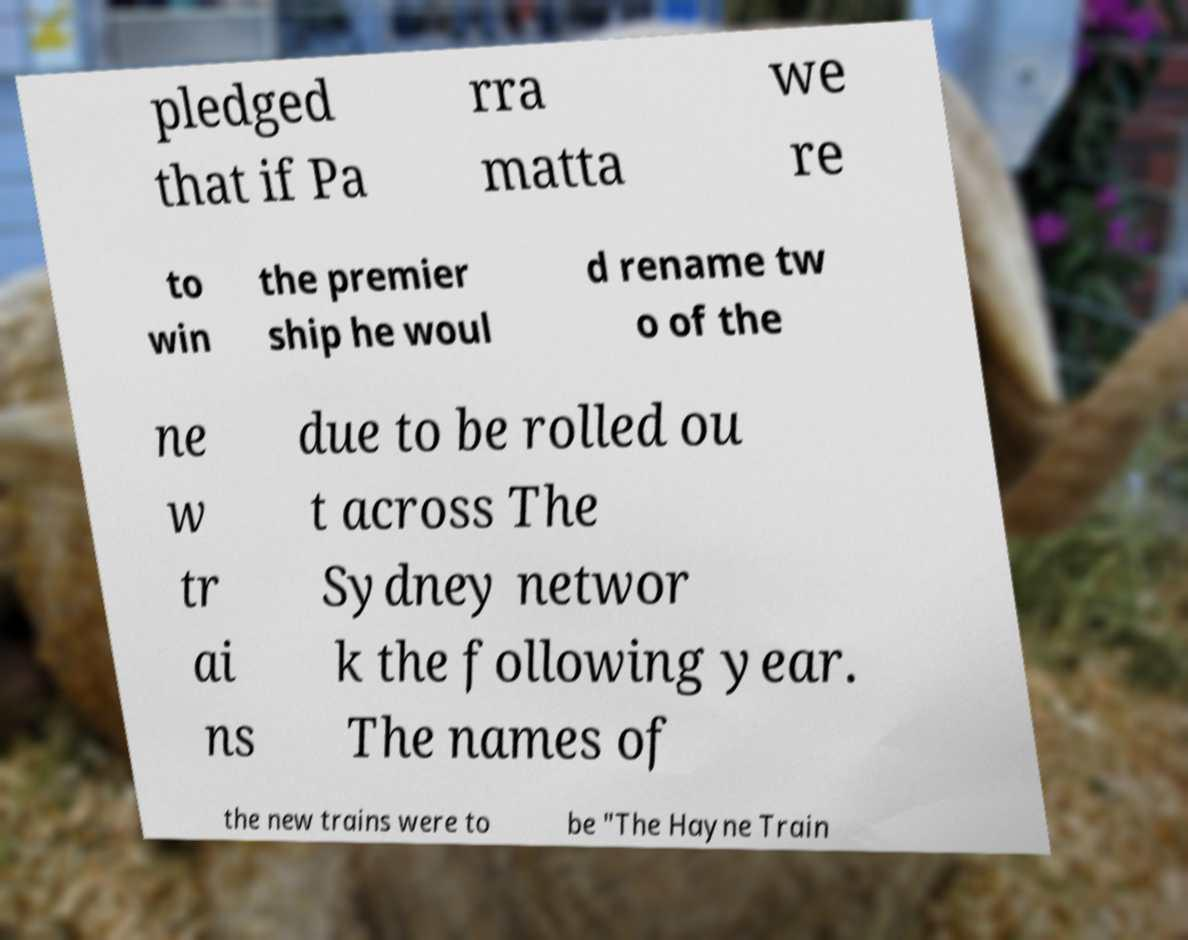Can you accurately transcribe the text from the provided image for me? pledged that if Pa rra matta we re to win the premier ship he woul d rename tw o of the ne w tr ai ns due to be rolled ou t across The Sydney networ k the following year. The names of the new trains were to be "The Hayne Train 